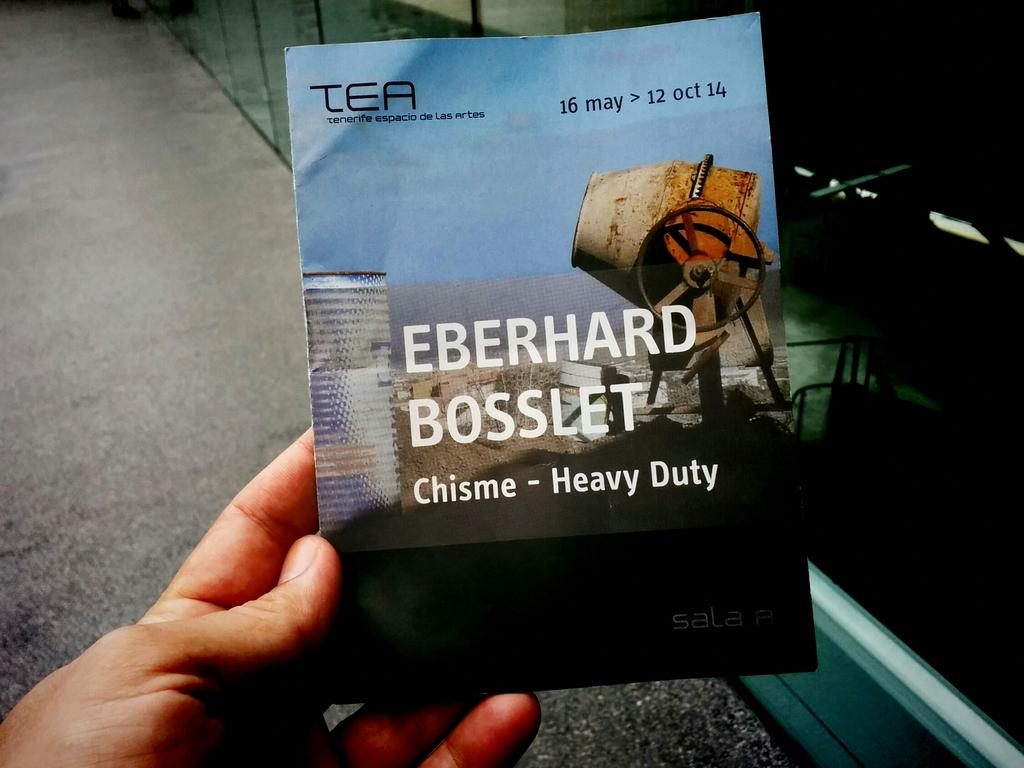<image>
Offer a succinct explanation of the picture presented. A person is holding a book with Eberhard Bosslet written on front. 